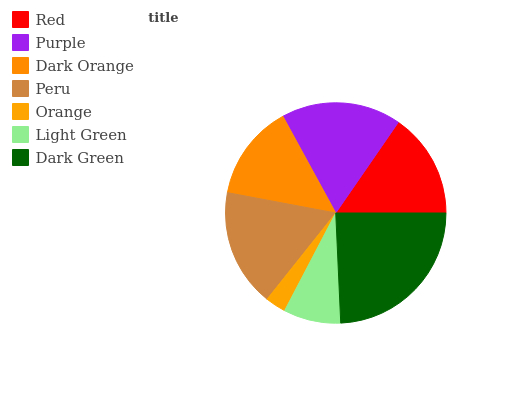Is Orange the minimum?
Answer yes or no. Yes. Is Dark Green the maximum?
Answer yes or no. Yes. Is Purple the minimum?
Answer yes or no. No. Is Purple the maximum?
Answer yes or no. No. Is Purple greater than Red?
Answer yes or no. Yes. Is Red less than Purple?
Answer yes or no. Yes. Is Red greater than Purple?
Answer yes or no. No. Is Purple less than Red?
Answer yes or no. No. Is Red the high median?
Answer yes or no. Yes. Is Red the low median?
Answer yes or no. Yes. Is Orange the high median?
Answer yes or no. No. Is Dark Orange the low median?
Answer yes or no. No. 